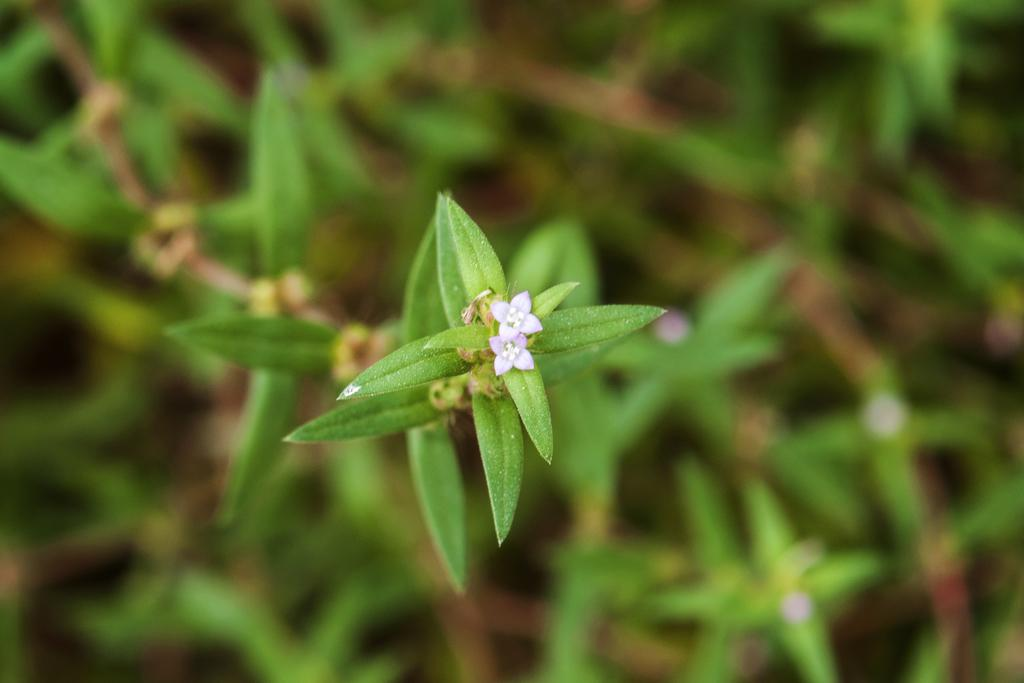What type of living organisms are in the picture? There are plants in the picture. What color are the flowers on the plants? The flowers on the plants are small and purple. Can you describe the background of the image? The backdrop of the image is blurred. How does the thunder affect the plants in the image? There is no thunder present in the image, so it cannot affect the plants. 